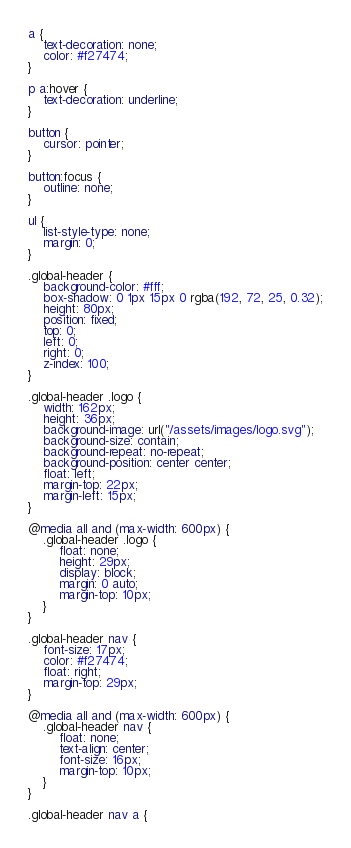<code> <loc_0><loc_0><loc_500><loc_500><_CSS_>a {
    text-decoration: none;
    color: #f27474;
}

p a:hover {
    text-decoration: underline;
}

button {
    cursor: pointer;
}

button:focus {
    outline: none;
}

ul {
    list-style-type: none;
    margin: 0;
}

.global-header {
    background-color: #fff;
    box-shadow: 0 1px 15px 0 rgba(192, 72, 25, 0.32);
    height: 80px;
    position: fixed;
    top: 0;
    left: 0;
    right: 0;
    z-index: 100;
}

.global-header .logo {
    width: 162px;
    height: 36px;
    background-image: url("/assets/images/logo.svg");
    background-size: contain;
    background-repeat: no-repeat;
    background-position: center center;
    float: left;
    margin-top: 22px;
    margin-left: 15px;
}

@media all and (max-width: 600px) {
    .global-header .logo {
        float: none;
        height: 29px;
        display: block;
        margin: 0 auto;
        margin-top: 10px;
    }
}

.global-header nav {
    font-size: 17px;
    color: #f27474;
    float: right;
    margin-top: 29px;
}

@media all and (max-width: 600px) {
    .global-header nav {
        float: none;
        text-align: center;
        font-size: 16px;
        margin-top: 10px;
    }
}

.global-header nav a {</code> 